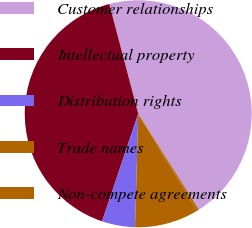Convert chart to OTSL. <chart><loc_0><loc_0><loc_500><loc_500><pie_chart><fcel>Customer relationships<fcel>Intellectual property<fcel>Distribution rights<fcel>Trade names<fcel>Non-compete agreements<nl><fcel>45.13%<fcel>40.73%<fcel>4.71%<fcel>9.11%<fcel>0.31%<nl></chart> 